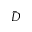Convert formula to latex. <formula><loc_0><loc_0><loc_500><loc_500>\bar { D }</formula> 